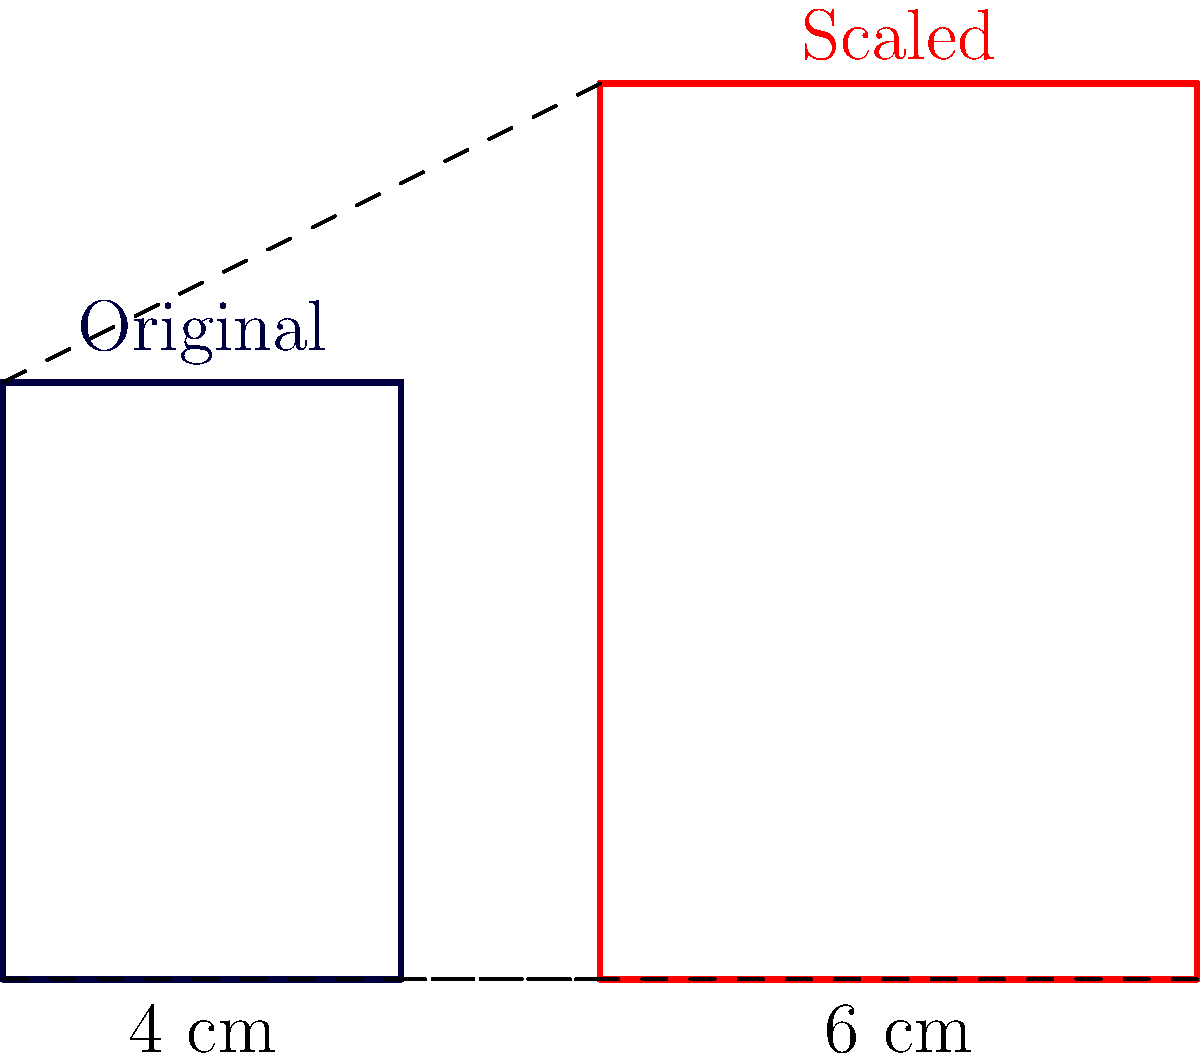As a versatile model, you're often asked to wear clothing in various sizes. A designer wants to scale up a rectangular clothing pattern for a photoshoot. The original pattern measures 4 cm wide and 6 cm long. If the scaled version is 6 cm wide, what is its length to maintain the same proportions? Let's approach this step-by-step:

1) First, we need to determine the scale factor. This is the ratio of the new width to the original width:
   Scale factor = New width / Original width
   $$ \text{Scale factor} = \frac{6 \text{ cm}}{4 \text{ cm}} = 1.5 $$

2) This means that all dimensions of the pattern will be multiplied by 1.5 to maintain the same proportions.

3) To find the new length, we multiply the original length by the scale factor:
   New length = Original length × Scale factor
   $$ \text{New length} = 6 \text{ cm} \times 1.5 = 9 \text{ cm} $$

4) We can verify this by checking if the ratio of length to width remains constant:
   Original ratio: $6/4 = 1.5$
   New ratio: $9/6 = 1.5$

Therefore, the length of the scaled version of the pattern is 9 cm.
Answer: 9 cm 